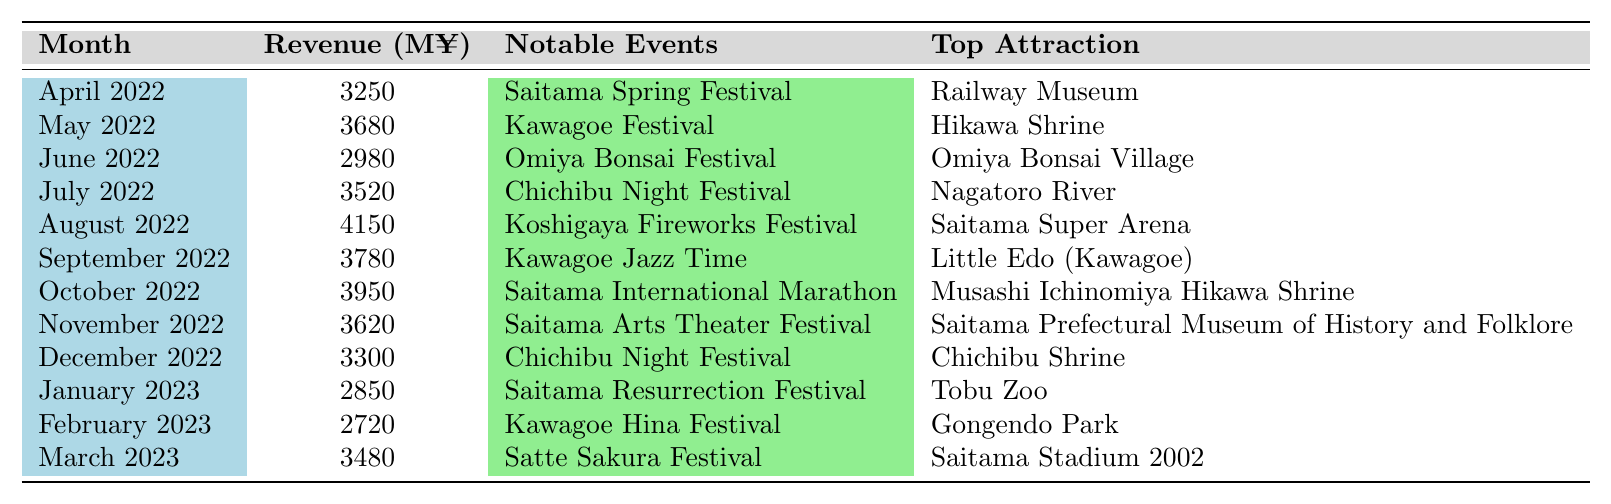What was the highest tourism revenue recorded in Saitama Prefecture over the past year? The highest revenue listed in the table is 4150 million yen, which occurred in August 2022.
Answer: 4150 million yen In which month did Saitama Prefecture see the lowest tourism revenue? The lowest revenue in the table is 2720 million yen, which occurred in February 2023.
Answer: February 2023 How much tourism revenue did Saitama Prefecture earn in October 2022? The revenue for October 2022 is listed as 3950 million yen.
Answer: 3950 million yen What is the average tourism revenue for the months listed in 2022? The total revenue for 2022 is the sum of revenues for April to December, which is (3250 + 3680 + 2980 + 3520 + 4150 + 3780 + 3950 + 3620 + 3300) = 32580 million yen. There are 9 months, so the average is 32580 / 9 = 3620 million yen.
Answer: 3620 million yen Was the Kawagoe Festival held in a month with higher or lower than average tourism revenue? The average revenue for the months listed is 3620 million yen. The revenue for May 2022, when the Kawagoe Festival occurred, is 3680 million yen, which is higher than the average.
Answer: Higher than average Which two months had tourism revenues close to each other, and what were those amounts? Looking at the table, November 2022 had 3620 million yen and December 2022 had 3300 million yen. These revenues are close, but not identical.
Answer: November: 3620 million yen, December: 3300 million yen Which notable event contributed to the highest revenue in August 2022? The notable event during August 2022 was the Koshigaya Fireworks Festival, which coincided with the highest revenue of 4150 million yen.
Answer: Koshigaya Fireworks Festival How does the tourism revenue in January 2023 compare to that of the previous year in January (2022)? In January 2023, the tourism revenue was 2850 million yen. The revenue in January 2022 isn't directly available in the table, but the previous data indicate a general upward trend over the year, suggesting January 2022 likely had higher revenue than January 2023.
Answer: Lower than January 2022 What notable event occurred in March 2023, and what was its revenue? The Satte Sakura Festival occurred in March 2023, generating a revenue of 3480 million yen.
Answer: Satte Sakura Festival, 3480 million yen Which month recorded a revenue of exactly 3300 million yen, and what was the notable event? December 2022 recorded a revenue of exactly 3300 million yen. The notable event during this month was the Chichibu Night Festival.
Answer: December 2022, Chichibu Night Festival 